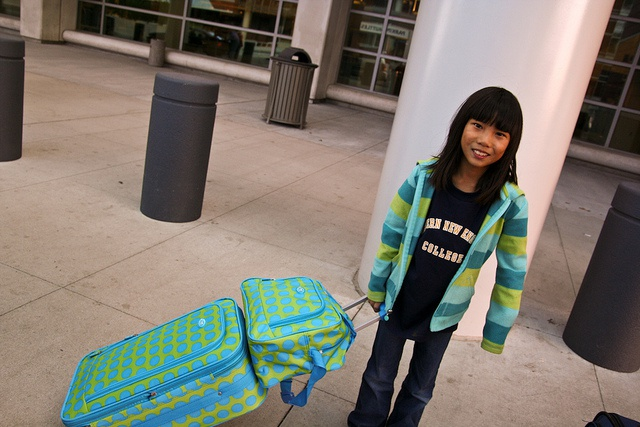Describe the objects in this image and their specific colors. I can see people in black, teal, and darkgray tones, suitcase in black, lightblue, olive, and teal tones, handbag in black, lightgreen, lightblue, and olive tones, and car in black, gray, and maroon tones in this image. 